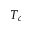<formula> <loc_0><loc_0><loc_500><loc_500>T _ { c }</formula> 